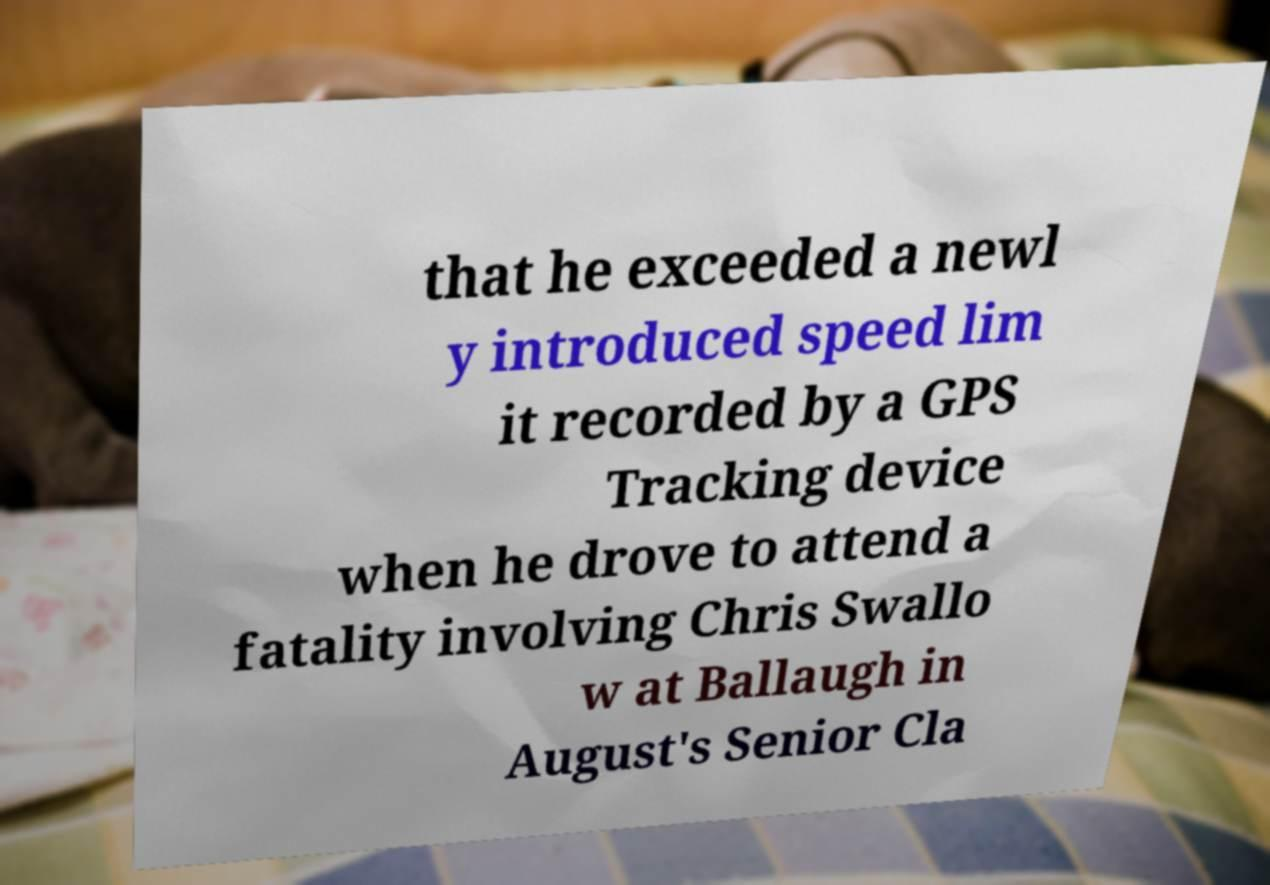There's text embedded in this image that I need extracted. Can you transcribe it verbatim? that he exceeded a newl y introduced speed lim it recorded by a GPS Tracking device when he drove to attend a fatality involving Chris Swallo w at Ballaugh in August's Senior Cla 